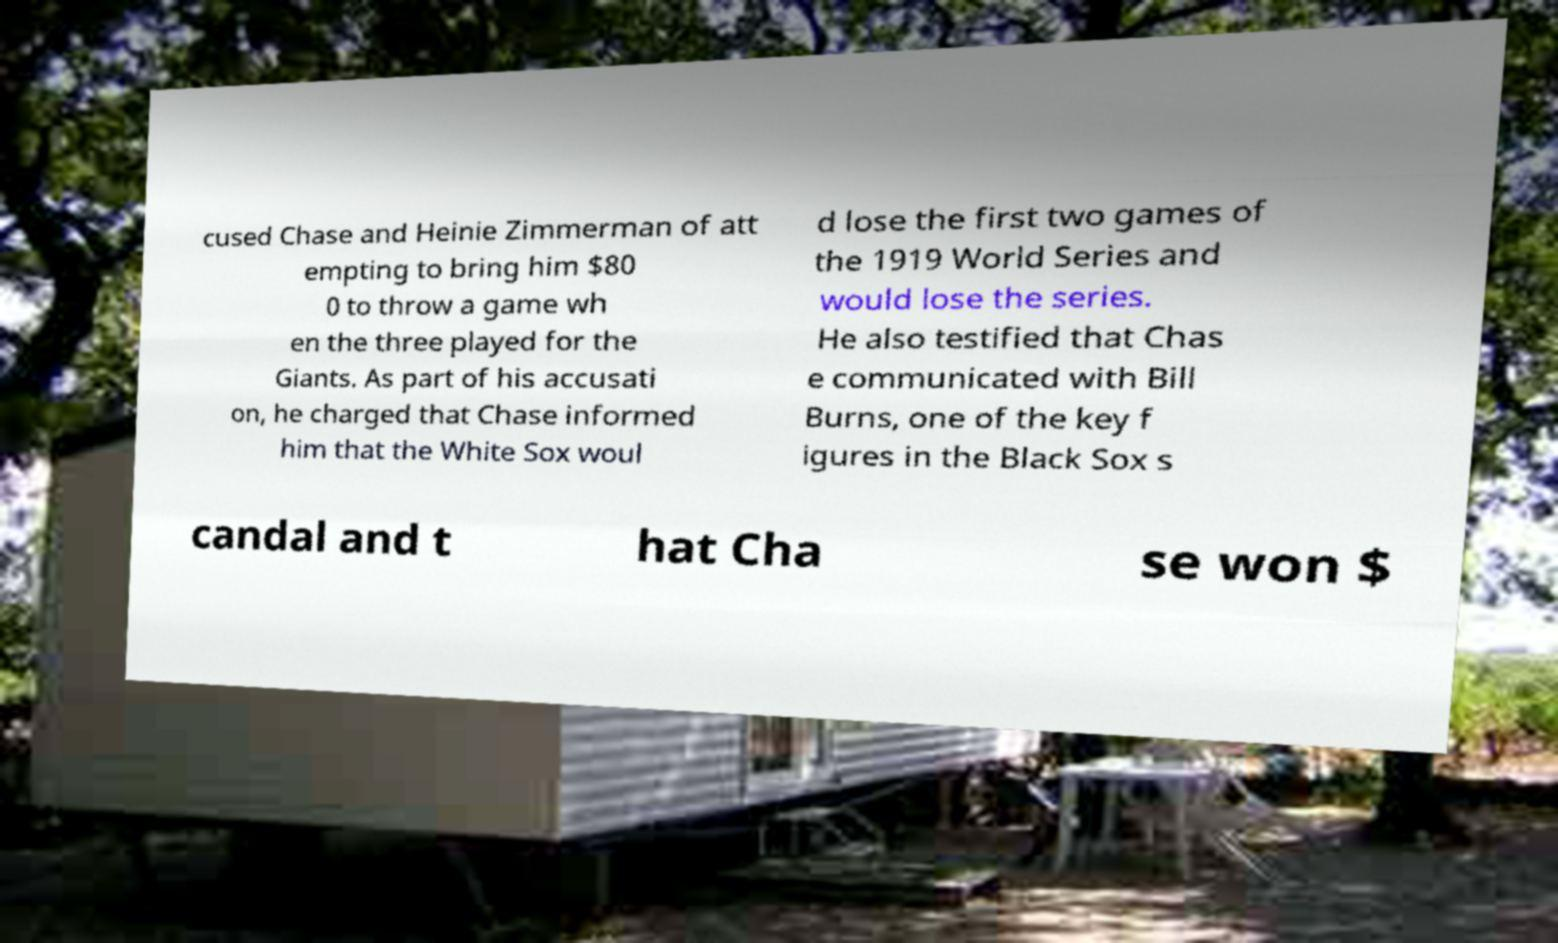Can you read and provide the text displayed in the image?This photo seems to have some interesting text. Can you extract and type it out for me? cused Chase and Heinie Zimmerman of att empting to bring him $80 0 to throw a game wh en the three played for the Giants. As part of his accusati on, he charged that Chase informed him that the White Sox woul d lose the first two games of the 1919 World Series and would lose the series. He also testified that Chas e communicated with Bill Burns, one of the key f igures in the Black Sox s candal and t hat Cha se won $ 